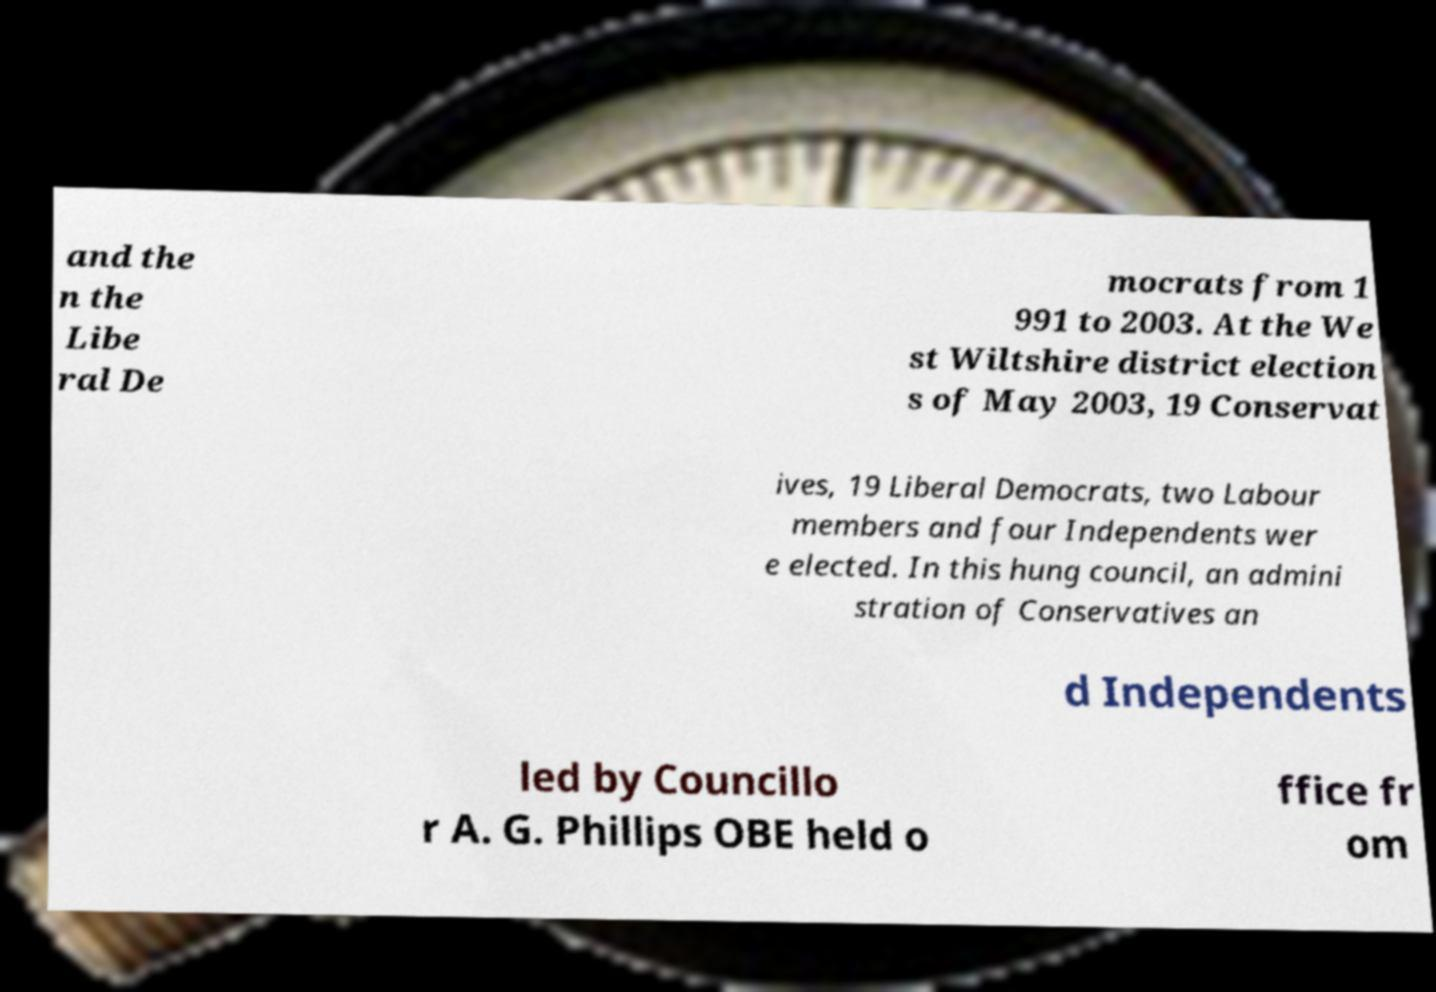Please identify and transcribe the text found in this image. and the n the Libe ral De mocrats from 1 991 to 2003. At the We st Wiltshire district election s of May 2003, 19 Conservat ives, 19 Liberal Democrats, two Labour members and four Independents wer e elected. In this hung council, an admini stration of Conservatives an d Independents led by Councillo r A. G. Phillips OBE held o ffice fr om 